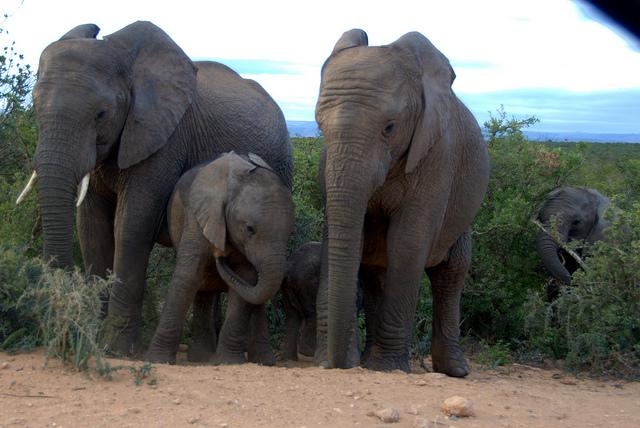How many animals are here?
Be succinct. 4. Are the animals been washed?
Keep it brief. No. Is one animal immature?
Short answer required. Yes. Are these elephants in a zoo?
Write a very short answer. No. Is the elephant in the very back being left behind?
Give a very brief answer. No. Why are the baby elephants ears turned downward?
Short answer required. Natural position. 